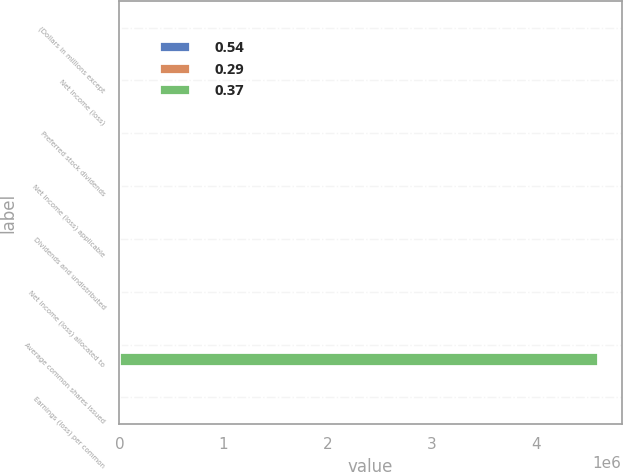<chart> <loc_0><loc_0><loc_500><loc_500><stacked_bar_chart><ecel><fcel>(Dollars in millions except<fcel>Net income (loss)<fcel>Preferred stock dividends<fcel>Net income (loss) applicable<fcel>Dividends and undistributed<fcel>Net income (loss) allocated to<fcel>Average common shares issued<fcel>Earnings (loss) per common<nl><fcel>0.54<fcel>2010<fcel>2238<fcel>1357<fcel>3595<fcel>4<fcel>3599<fcel>2107<fcel>0.37<nl><fcel>0.29<fcel>2009<fcel>6276<fcel>4494<fcel>2204<fcel>6<fcel>2210<fcel>2107<fcel>0.29<nl><fcel>0.37<fcel>2008<fcel>4008<fcel>1452<fcel>2556<fcel>69<fcel>2487<fcel>4.59208e+06<fcel>0.54<nl></chart> 